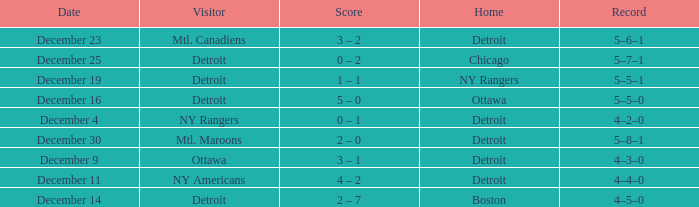What score has detroit as the home, and December 9 as the date? 3 – 1. 